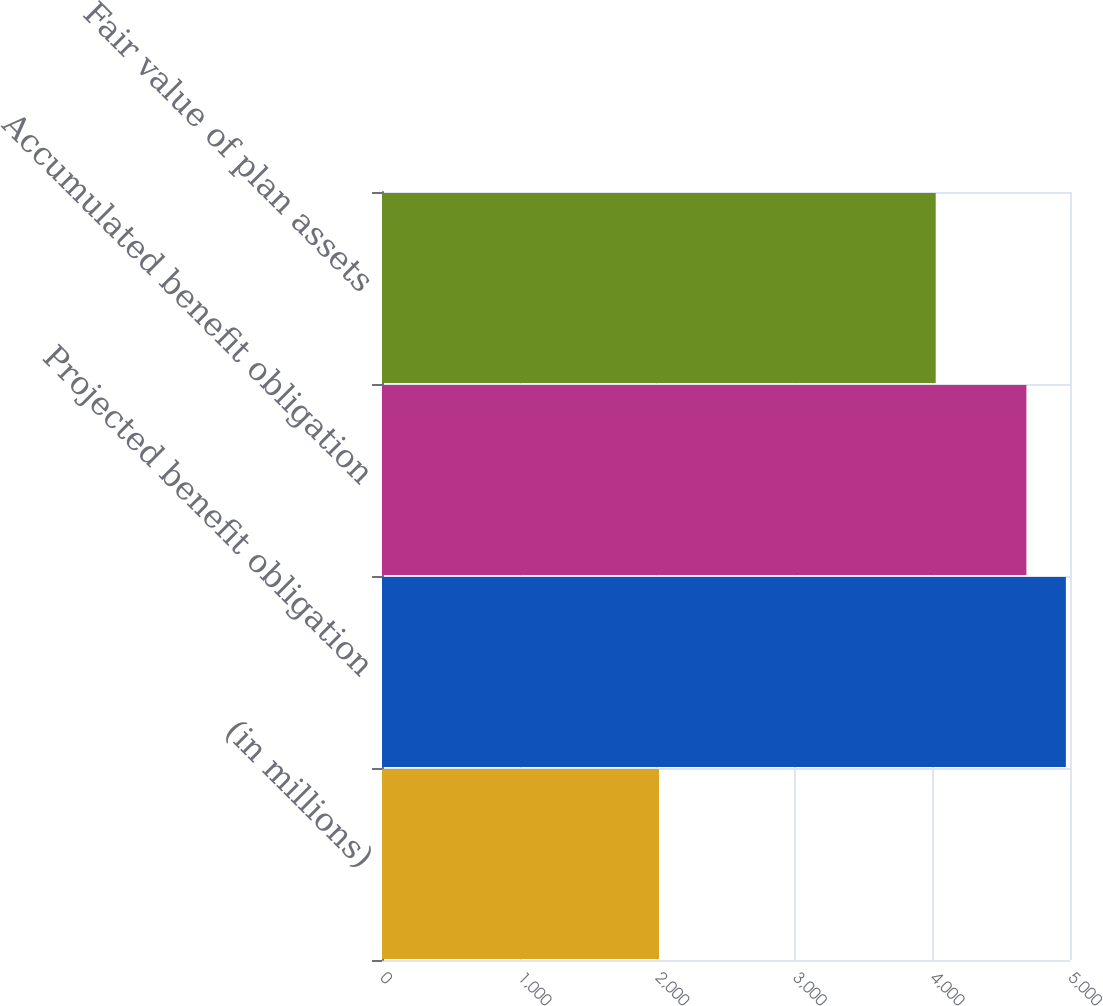Convert chart to OTSL. <chart><loc_0><loc_0><loc_500><loc_500><bar_chart><fcel>(in millions)<fcel>Projected benefit obligation<fcel>Accumulated benefit obligation<fcel>Fair value of plan assets<nl><fcel>2013<fcel>4969.9<fcel>4683<fcel>4024<nl></chart> 